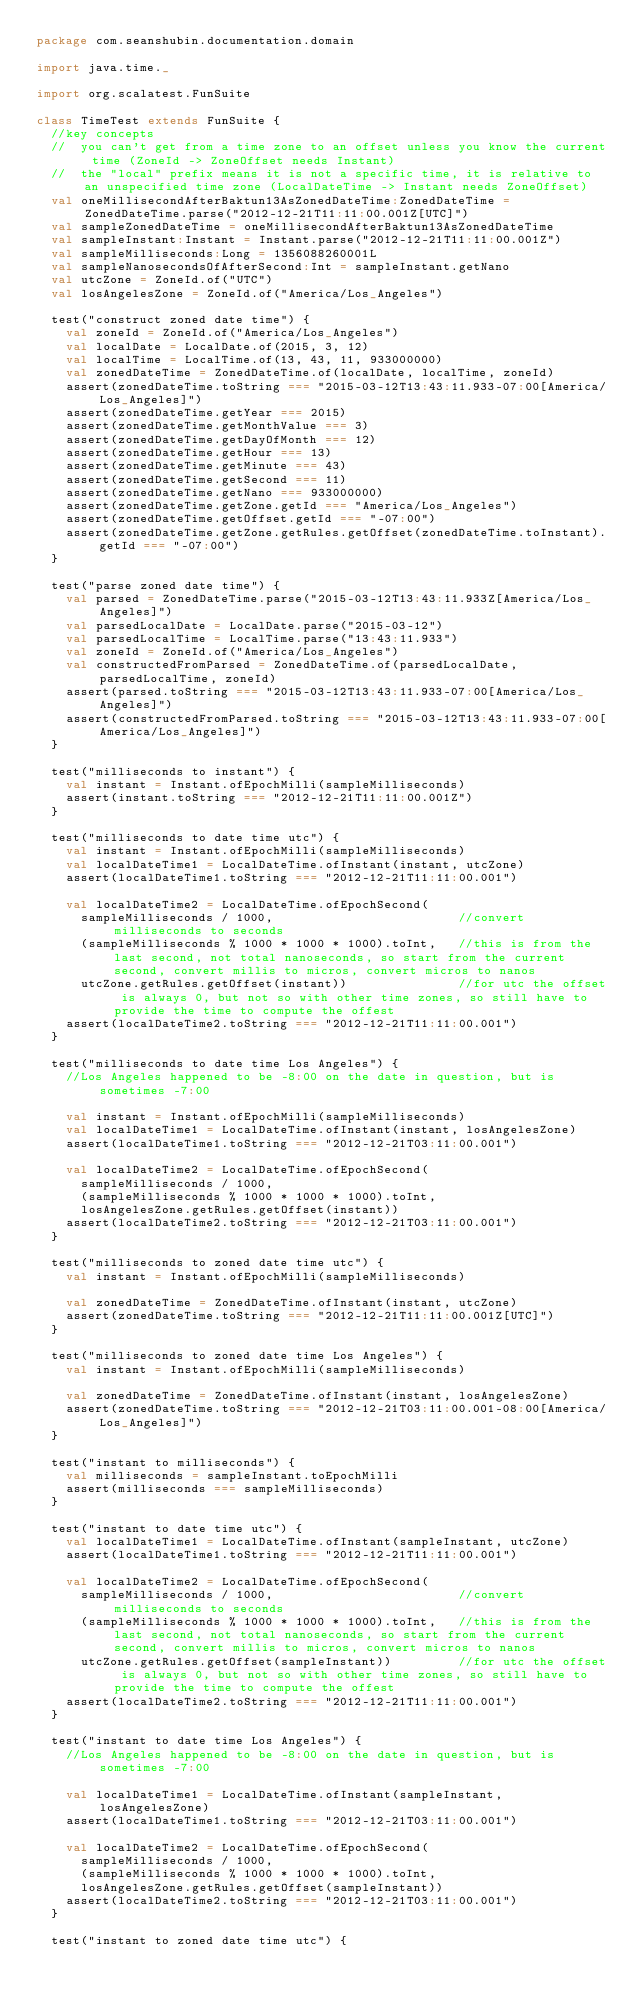Convert code to text. <code><loc_0><loc_0><loc_500><loc_500><_Scala_>package com.seanshubin.documentation.domain

import java.time._

import org.scalatest.FunSuite

class TimeTest extends FunSuite {
  //key concepts
  //  you can't get from a time zone to an offset unless you know the current time (ZoneId -> ZoneOffset needs Instant)
  //  the "local" prefix means it is not a specific time, it is relative to an unspecified time zone (LocalDateTime -> Instant needs ZoneOffset)
  val oneMillisecondAfterBaktun13AsZonedDateTime:ZonedDateTime = ZonedDateTime.parse("2012-12-21T11:11:00.001Z[UTC]")
  val sampleZonedDateTime = oneMillisecondAfterBaktun13AsZonedDateTime
  val sampleInstant:Instant = Instant.parse("2012-12-21T11:11:00.001Z")
  val sampleMilliseconds:Long = 1356088260001L
  val sampleNanosecondsOfAfterSecond:Int = sampleInstant.getNano
  val utcZone = ZoneId.of("UTC")
  val losAngelesZone = ZoneId.of("America/Los_Angeles")

  test("construct zoned date time") {
    val zoneId = ZoneId.of("America/Los_Angeles")
    val localDate = LocalDate.of(2015, 3, 12)
    val localTime = LocalTime.of(13, 43, 11, 933000000)
    val zonedDateTime = ZonedDateTime.of(localDate, localTime, zoneId)
    assert(zonedDateTime.toString === "2015-03-12T13:43:11.933-07:00[America/Los_Angeles]")
    assert(zonedDateTime.getYear === 2015)
    assert(zonedDateTime.getMonthValue === 3)
    assert(zonedDateTime.getDayOfMonth === 12)
    assert(zonedDateTime.getHour === 13)
    assert(zonedDateTime.getMinute === 43)
    assert(zonedDateTime.getSecond === 11)
    assert(zonedDateTime.getNano === 933000000)
    assert(zonedDateTime.getZone.getId === "America/Los_Angeles")
    assert(zonedDateTime.getOffset.getId === "-07:00")
    assert(zonedDateTime.getZone.getRules.getOffset(zonedDateTime.toInstant).getId === "-07:00")
  }

  test("parse zoned date time") {
    val parsed = ZonedDateTime.parse("2015-03-12T13:43:11.933Z[America/Los_Angeles]")
    val parsedLocalDate = LocalDate.parse("2015-03-12")
    val parsedLocalTime = LocalTime.parse("13:43:11.933")
    val zoneId = ZoneId.of("America/Los_Angeles")
    val constructedFromParsed = ZonedDateTime.of(parsedLocalDate, parsedLocalTime, zoneId)
    assert(parsed.toString === "2015-03-12T13:43:11.933-07:00[America/Los_Angeles]")
    assert(constructedFromParsed.toString === "2015-03-12T13:43:11.933-07:00[America/Los_Angeles]")
  }

  test("milliseconds to instant") {
    val instant = Instant.ofEpochMilli(sampleMilliseconds)
    assert(instant.toString === "2012-12-21T11:11:00.001Z")
  }

  test("milliseconds to date time utc") {
    val instant = Instant.ofEpochMilli(sampleMilliseconds)
    val localDateTime1 = LocalDateTime.ofInstant(instant, utcZone)
    assert(localDateTime1.toString === "2012-12-21T11:11:00.001")

    val localDateTime2 = LocalDateTime.ofEpochSecond(
      sampleMilliseconds / 1000,                         //convert milliseconds to seconds
      (sampleMilliseconds % 1000 * 1000 * 1000).toInt,   //this is from the last second, not total nanoseconds, so start from the current second, convert millis to micros, convert micros to nanos
      utcZone.getRules.getOffset(instant))               //for utc the offset is always 0, but not so with other time zones, so still have to provide the time to compute the offest
    assert(localDateTime2.toString === "2012-12-21T11:11:00.001")
  }

  test("milliseconds to date time Los Angeles") {
    //Los Angeles happened to be -8:00 on the date in question, but is sometimes -7:00

    val instant = Instant.ofEpochMilli(sampleMilliseconds)
    val localDateTime1 = LocalDateTime.ofInstant(instant, losAngelesZone)
    assert(localDateTime1.toString === "2012-12-21T03:11:00.001")

    val localDateTime2 = LocalDateTime.ofEpochSecond(
      sampleMilliseconds / 1000,
      (sampleMilliseconds % 1000 * 1000 * 1000).toInt,
      losAngelesZone.getRules.getOffset(instant))
    assert(localDateTime2.toString === "2012-12-21T03:11:00.001")
  }

  test("milliseconds to zoned date time utc") {
    val instant = Instant.ofEpochMilli(sampleMilliseconds)

    val zonedDateTime = ZonedDateTime.ofInstant(instant, utcZone)
    assert(zonedDateTime.toString === "2012-12-21T11:11:00.001Z[UTC]")
  }

  test("milliseconds to zoned date time Los Angeles") {
    val instant = Instant.ofEpochMilli(sampleMilliseconds)

    val zonedDateTime = ZonedDateTime.ofInstant(instant, losAngelesZone)
    assert(zonedDateTime.toString === "2012-12-21T03:11:00.001-08:00[America/Los_Angeles]")
  }

  test("instant to milliseconds") {
    val milliseconds = sampleInstant.toEpochMilli
    assert(milliseconds === sampleMilliseconds)
  }

  test("instant to date time utc") {
    val localDateTime1 = LocalDateTime.ofInstant(sampleInstant, utcZone)
    assert(localDateTime1.toString === "2012-12-21T11:11:00.001")

    val localDateTime2 = LocalDateTime.ofEpochSecond(
      sampleMilliseconds / 1000,                         //convert milliseconds to seconds
      (sampleMilliseconds % 1000 * 1000 * 1000).toInt,   //this is from the last second, not total nanoseconds, so start from the current second, convert millis to micros, convert micros to nanos
      utcZone.getRules.getOffset(sampleInstant))         //for utc the offset is always 0, but not so with other time zones, so still have to provide the time to compute the offest
    assert(localDateTime2.toString === "2012-12-21T11:11:00.001")
  }

  test("instant to date time Los Angeles") {
    //Los Angeles happened to be -8:00 on the date in question, but is sometimes -7:00

    val localDateTime1 = LocalDateTime.ofInstant(sampleInstant, losAngelesZone)
    assert(localDateTime1.toString === "2012-12-21T03:11:00.001")

    val localDateTime2 = LocalDateTime.ofEpochSecond(
      sampleMilliseconds / 1000,
      (sampleMilliseconds % 1000 * 1000 * 1000).toInt,
      losAngelesZone.getRules.getOffset(sampleInstant))
    assert(localDateTime2.toString === "2012-12-21T03:11:00.001")
  }

  test("instant to zoned date time utc") {</code> 